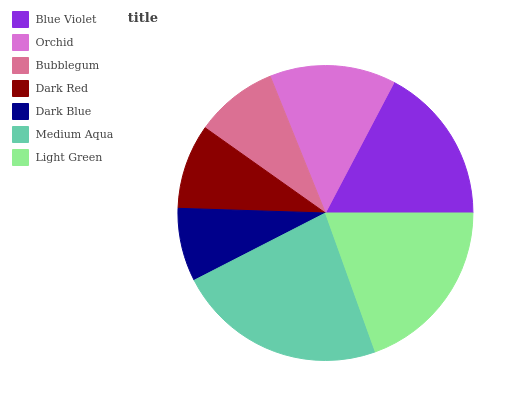Is Dark Blue the minimum?
Answer yes or no. Yes. Is Medium Aqua the maximum?
Answer yes or no. Yes. Is Orchid the minimum?
Answer yes or no. No. Is Orchid the maximum?
Answer yes or no. No. Is Blue Violet greater than Orchid?
Answer yes or no. Yes. Is Orchid less than Blue Violet?
Answer yes or no. Yes. Is Orchid greater than Blue Violet?
Answer yes or no. No. Is Blue Violet less than Orchid?
Answer yes or no. No. Is Orchid the high median?
Answer yes or no. Yes. Is Orchid the low median?
Answer yes or no. Yes. Is Bubblegum the high median?
Answer yes or no. No. Is Bubblegum the low median?
Answer yes or no. No. 